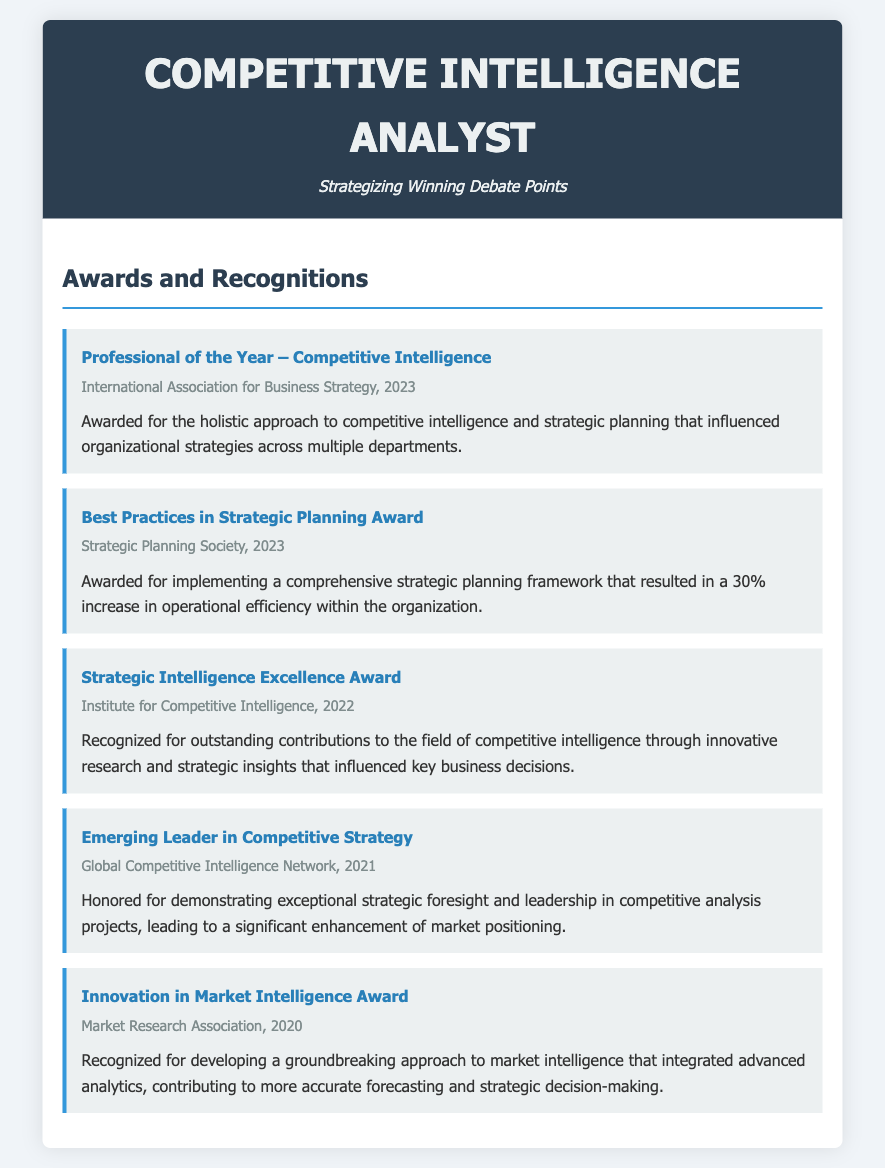what award was received for a comprehensive strategic planning framework? The award given for implementing a comprehensive strategic planning framework that improved operational efficiency is named "Best Practices in Strategic Planning Award."
Answer: Best Practices in Strategic Planning Award which organization awarded the Professional of the Year? The Professional of the Year award was given by the International Association for Business Strategy.
Answer: International Association for Business Strategy what year was the Innovation in Market Intelligence Award received? The award for innovation in market intelligence was received in the year 2020, as stated in the document.
Answer: 2020 how much did operational efficiency increase due to the strategic planning framework? The document specifies that the operational efficiency increased by 30% as a result of implementing the framework.
Answer: 30% who recognized outstanding contributions to competitive intelligence in 2022? The Institute for Competitive Intelligence recognized the outstanding contributions to this field in 2022.
Answer: Institute for Competitive Intelligence what was the main achievement for the Emerging Leader in Competitive Strategy award? The main achievement noted for this award was the demonstration of exceptional strategic foresight and leadership in competitive analysis projects.
Answer: Exceptional strategic foresight and leadership how many awards were listed in the document? The total number of awards mentioned in the document is five, as indicated throughout the document.
Answer: Five which award was associated with a 2021 recognition? The award associated with the year 2021 is the "Emerging Leader in Competitive Strategy."
Answer: Emerging Leader in Competitive Strategy what did the Innovation in Market Intelligence Award contribute to? It contributed to more accurate forecasting and strategic decision-making through advanced analytics integration.
Answer: More accurate forecasting and strategic decision-making 